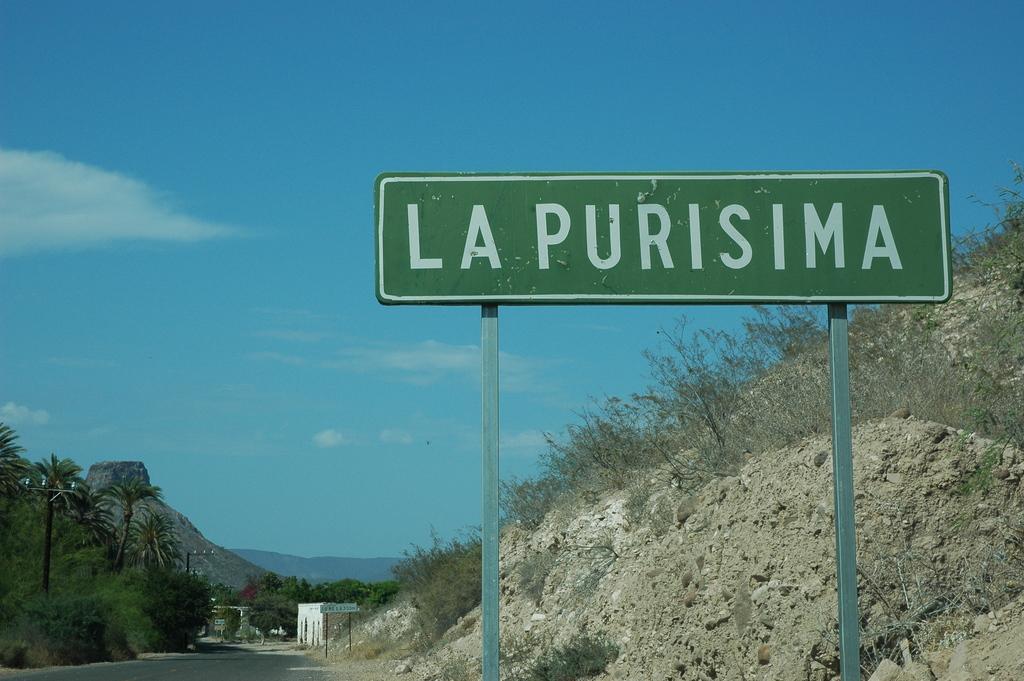Describe this image in one or two sentences. In front of the image there are boards with some text on it. There is a road. There are poles. There are trees. In the background of the image there are buildings, mountains. At the top of the image there are clouds in the sky. 